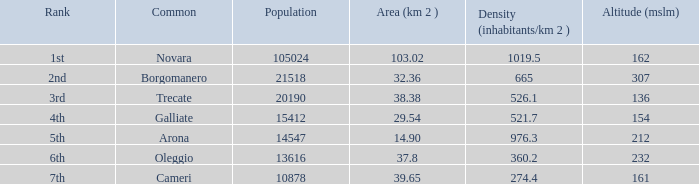Which common has an area (km2) of 38.38? Trecate. 